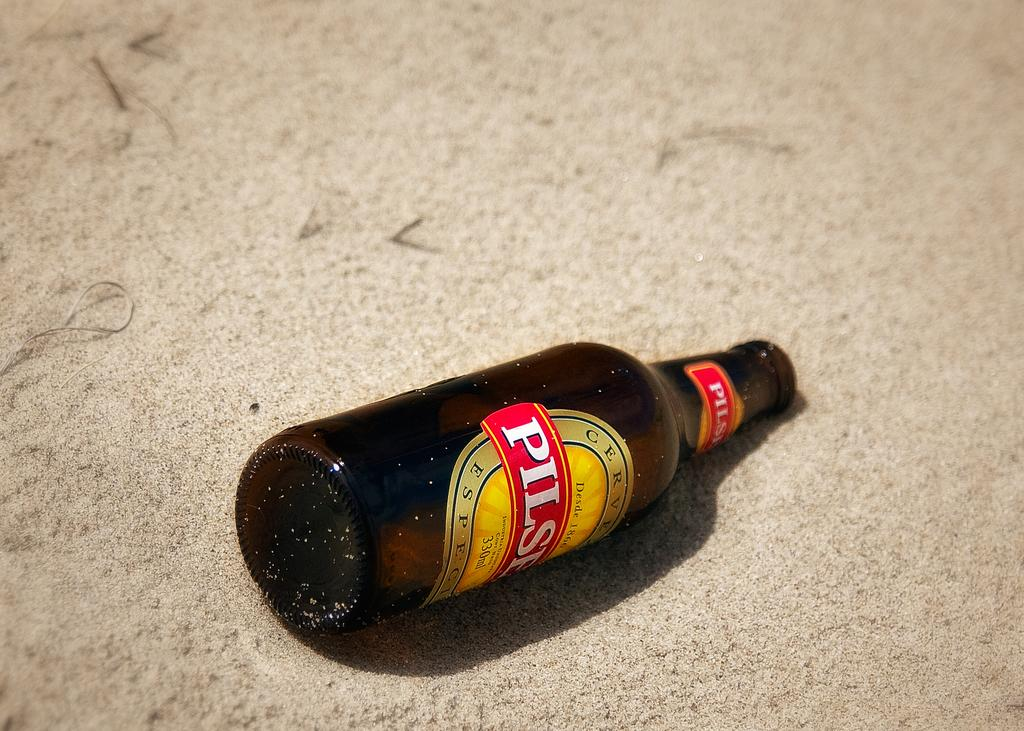<image>
Offer a succinct explanation of the picture presented. an empty bottle labelled pilser laying neck down in the sand 